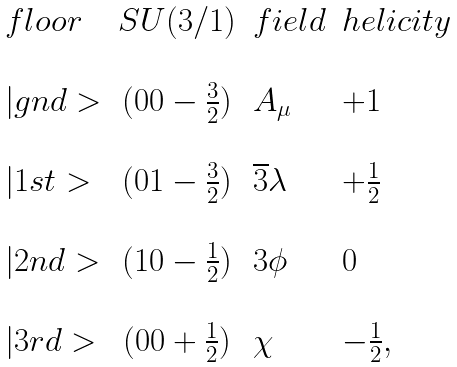Convert formula to latex. <formula><loc_0><loc_0><loc_500><loc_500>\begin{array} { l c l l } f l o o r & S U ( 3 / 1 ) & f i e l d & h e l i c i t y \\ \\ | g n d > & ( 0 0 - \frac { 3 } { 2 } ) & A _ { \mu } & + 1 \\ \\ | 1 s t > & ( 0 1 - \frac { 3 } { 2 } ) & \overline { 3 } \lambda & + \frac { 1 } { 2 } \\ \\ | 2 n d > & ( 1 0 - \frac { 1 } { 2 } ) & 3 \phi & 0 \\ \\ | 3 r d > & ( 0 0 + \frac { 1 } { 2 } ) & \chi & - \frac { 1 } { 2 } , \\ \end{array}</formula> 